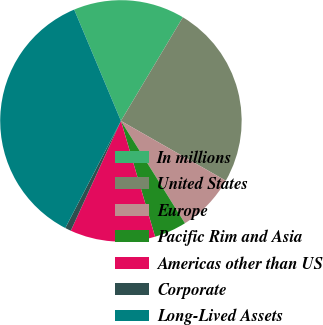Convert chart to OTSL. <chart><loc_0><loc_0><loc_500><loc_500><pie_chart><fcel>In millions<fcel>United States<fcel>Europe<fcel>Pacific Rim and Asia<fcel>Americas other than US<fcel>Corporate<fcel>Long-Lived Assets<nl><fcel>14.91%<fcel>24.67%<fcel>7.86%<fcel>4.33%<fcel>11.38%<fcel>0.81%<fcel>36.05%<nl></chart> 